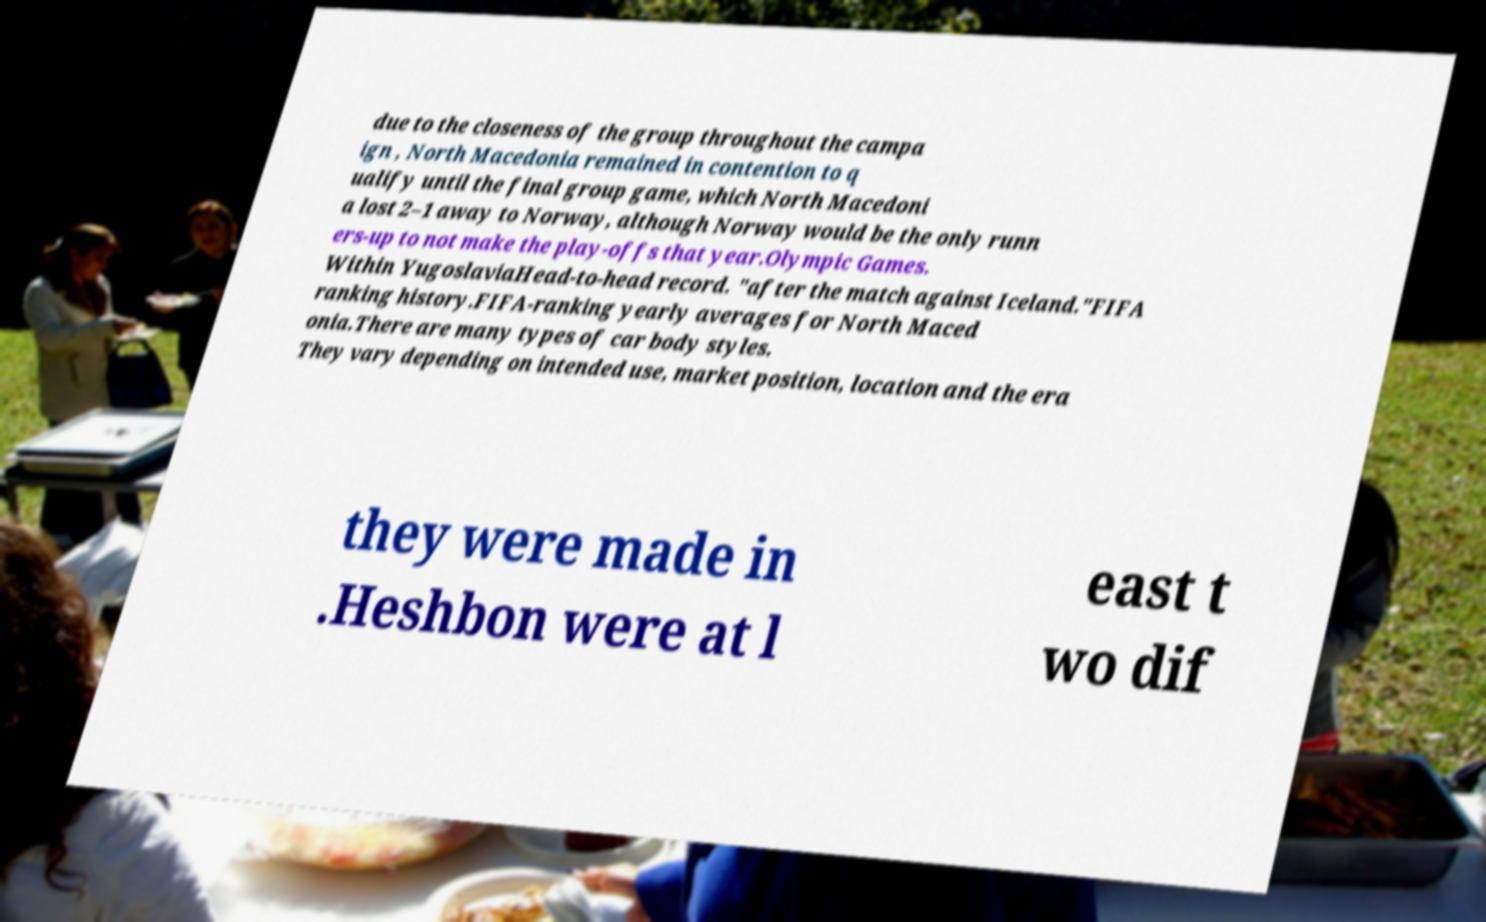Please read and relay the text visible in this image. What does it say? due to the closeness of the group throughout the campa ign , North Macedonia remained in contention to q ualify until the final group game, which North Macedoni a lost 2–1 away to Norway, although Norway would be the only runn ers-up to not make the play-offs that year.Olympic Games. Within YugoslaviaHead-to-head record. "after the match against Iceland."FIFA ranking history.FIFA-ranking yearly averages for North Maced onia.There are many types of car body styles. They vary depending on intended use, market position, location and the era they were made in .Heshbon were at l east t wo dif 